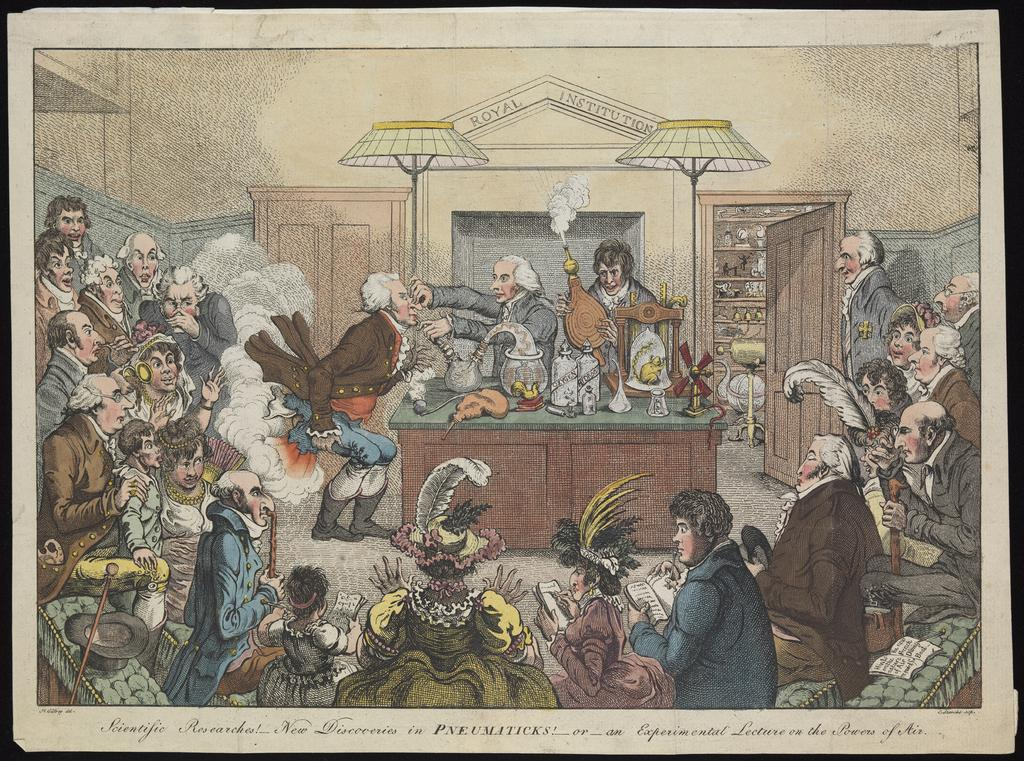Provide a one-sentence caption for the provided image. Drawing of politicans having a meeting and the word "Pneumaticks" on the bottom. 